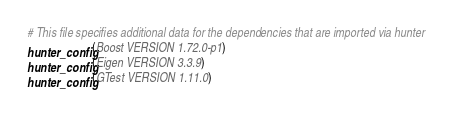Convert code to text. <code><loc_0><loc_0><loc_500><loc_500><_CMake_># This file specifies additional data for the dependencies that are imported via hunter
hunter_config(Boost VERSION 1.72.0-p1)
hunter_config(Eigen VERSION 3.3.9)
hunter_config(GTest VERSION 1.11.0)
</code> 